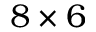<formula> <loc_0><loc_0><loc_500><loc_500>8 \times 6</formula> 